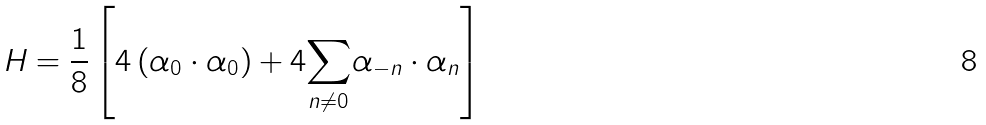Convert formula to latex. <formula><loc_0><loc_0><loc_500><loc_500>H = \frac { 1 } { 8 } \left [ 4 \left ( \alpha _ { 0 } \cdot \alpha _ { 0 } \right ) + 4 \underset { n \neq 0 } { \sum } \alpha _ { - n } \cdot \alpha _ { n } \right ]</formula> 